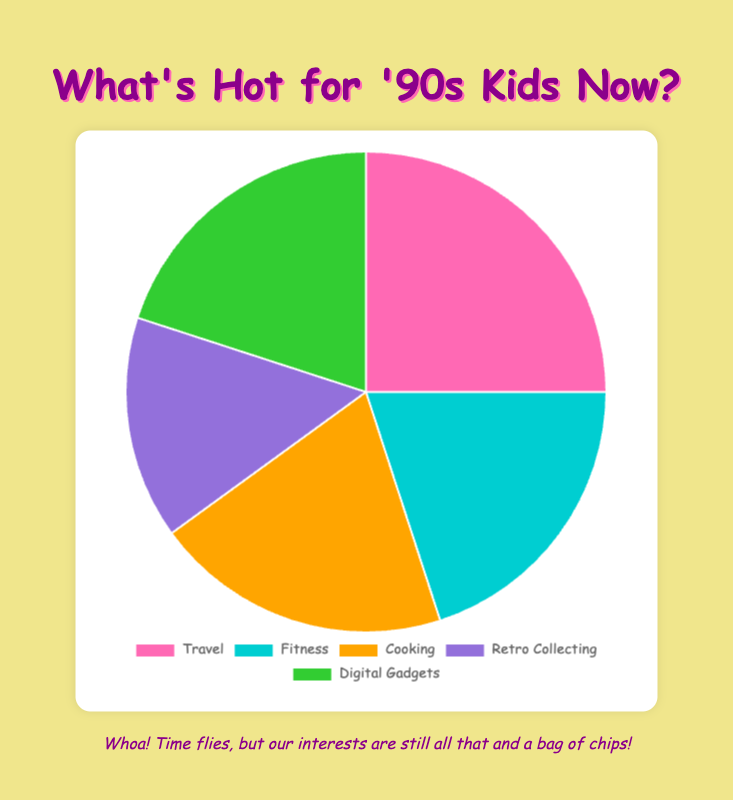What percentage of 40-somethings who were teenagers in the '90s are interested in both Fitness and Cooking? Summing the percentages for Fitness (20%) and Cooking (20%) gives us 20% + 20% = 40%.
Answer: 40% Which category has the largest percentage of interest among 40-somethings who were teenagers in the '90s? The category with the largest percentage is Travel at 25%.
Answer: Travel How does the percentage of those interested in Retro Collecting compare to those interested in Fitness and Cooking combined? The percentage of interest in Retro Collecting is 15%, while the combined percentage for Fitness and Cooking is 20% + 20% = 40%. Retro Collecting (15%) is less than Fitness and Cooking combined (40%).
Answer: Less than Which category is represented by the color orange in the pie chart? The color orange represents the category of Cooking, having 20% interest.
Answer: Cooking What are the second most popular interests among 40-somethings who were teenagers in the '90s? The second most popular interests, each with 20%, are Fitness, Cooking, and Digital Gadgets.
Answer: Fitness, Cooking, Digital Gadgets What is the difference in popularity between Travel and Retro Collecting? The percentage for Travel is 25%, and for Retro Collecting, it is 15%. The difference is 25% - 15% = 10%.
Answer: 10% How do the interests in Digital Gadgets and Retro Collecting compare visually in terms of color? Digital Gadgets is represented by the color green, and Retro Collecting is represented by the color purple.
Answer: Green vs. Purple What two interests combined equal the same percentage as those interested in Travel? The interests in Fitness and Digital Gadgets both have 20% each, and any two, when combined, give 20% + 20% = 40%, but the correct combination with Travel's 25% would not be available here, so it's just combined interest matches like a maximum closest.
Answer: None If you were to combine the interests of Digital Gadgets, Fitness, and Cooking, what would be the total percentage? Summing the percentages for Digital Gadgets (20%), Fitness (20%), and Cooking (20%) gives us 20% + 20% + 20% = 60%.
Answer: 60% Which interest has the lowest representation on the pie chart, and what percentage does it have? The category with the lowest representation is Retro Collecting, with 15% interest.
Answer: Retro Collecting, 15% 